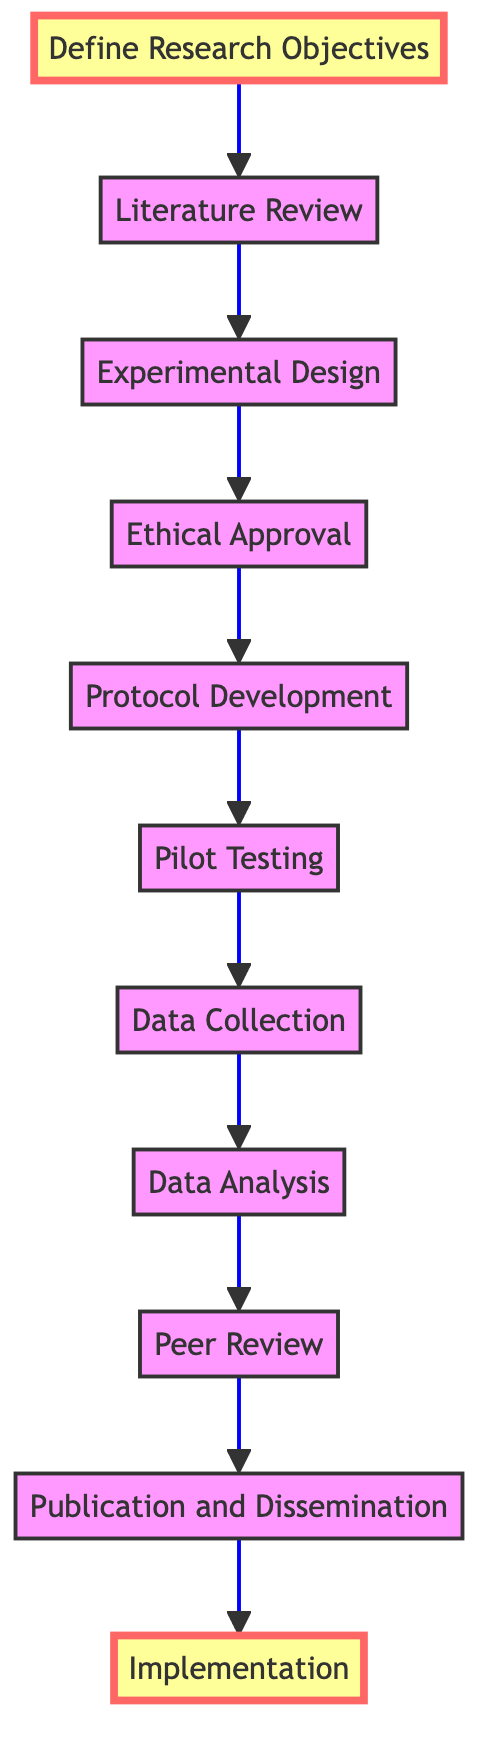What is the last step in the flow chart? According to the flow chart, the last step is "Implementation." This step is indicated at the top of the flow chart, representing the final stage after all previous steps have been completed.
Answer: Implementation How many steps are in the flow chart? The flow chart contains a total of eleven steps, from "Define Research Objectives" at the bottom to "Implementation" at the top. Each step is a distinct part of the process.
Answer: 11 What comes immediately before "Data Analysis"? The step that comes immediately before "Data Analysis" is "Data Collection." This can be determined by following the arrows leading toward "Data Analysis."
Answer: Data Collection What is the purpose of the "Pilot Testing" step? The "Pilot Testing" step aims to conduct initial pilot tests to identify potential issues and refine the methodology. This purpose is directly stated in the description of that step in the flow chart.
Answer: Identify issues Which step follows "Ethical Approval"? The step that follows "Ethical Approval" is "Protocol Development," as indicated by the arrow pointing upward from "Ethical Approval" to "Protocol Development."
Answer: Protocol Development Does the flow chart suggest a circular process? No, the flow chart does not suggest a circular process. It indicates a linear progression from bottom to top, where each step leads to the next without looping back.
Answer: No What is the focus of the first step in the flow chart? The focus of the first step, "Define Research Objectives," is to clearly outline the goals and hypotheses of the new research methodology. This initial step sets the stage for all subsequent steps.
Answer: Outline goals What is the relationship between "Peer Review" and "Publication and Dissemination"? The relationship is sequential; "Peer Review" must occur before "Publication and Dissemination," indicating that findings and methodology must be validated by peers before being published or disseminated.
Answer: Sequential relationship What is the key focus in the "Data Collection" step? The key focus in the "Data Collection" step is to implement the methodology to collect data while utilizing advanced data acquisition technologies. This highlights the importance of technology in the data collection process.
Answer: Advanced technologies 